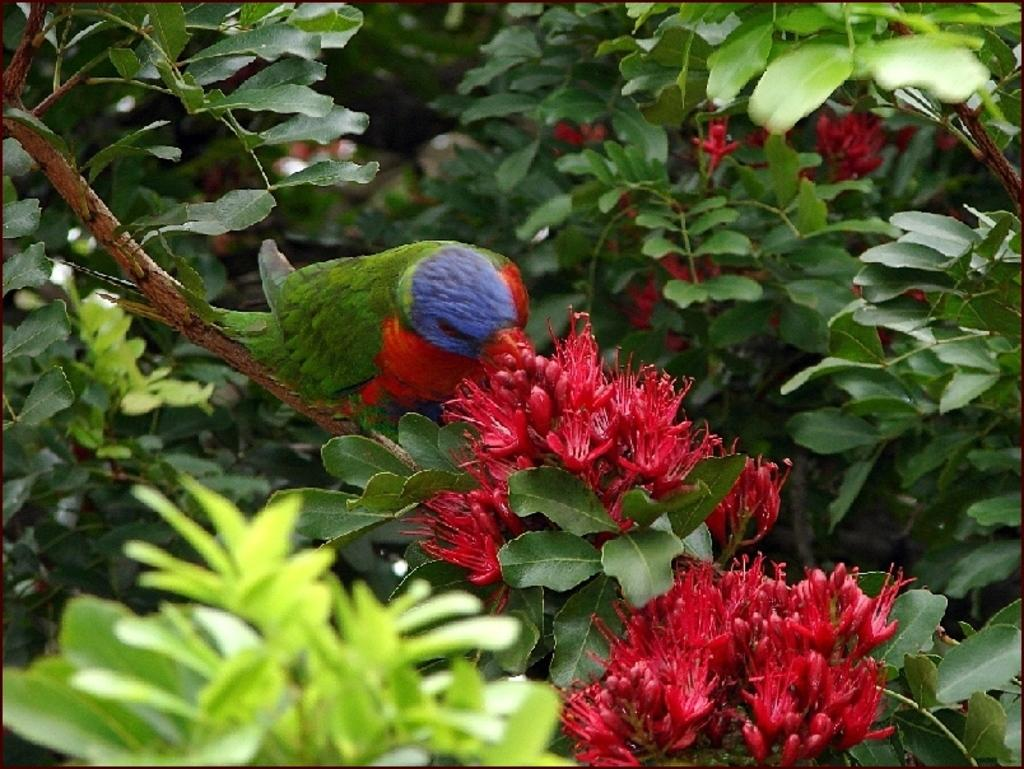What type of animal can be seen in the image? There is a bird in the image. What kind of plants are present in the image? There are red color flower plants in the image. Where is the cap located in the image? There is no cap present in the image. Can you see an airport in the image? There is no airport present in the image. 